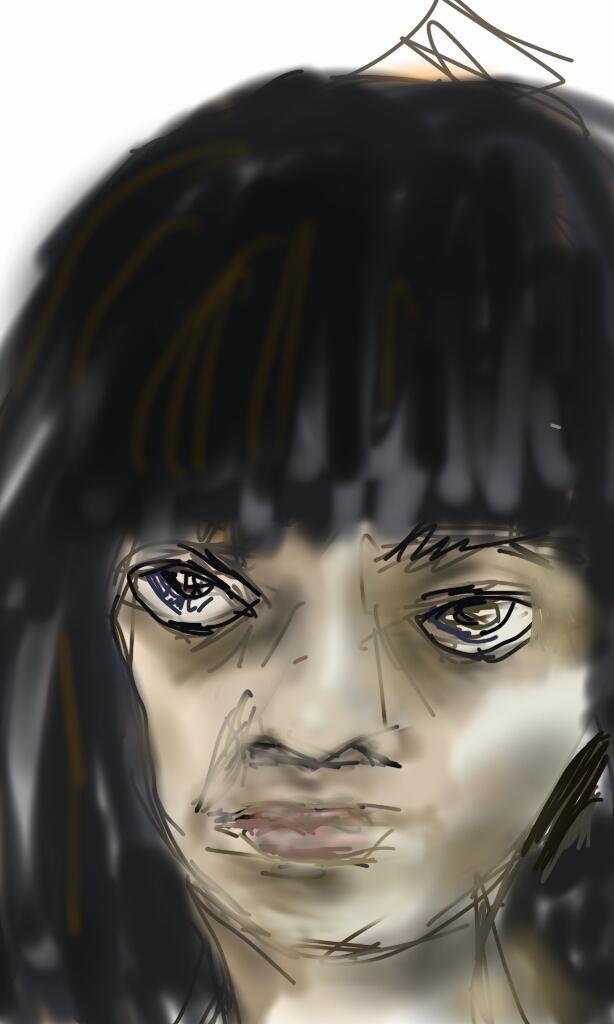In one or two sentences, can you explain what this image depicts? This picture is consists of a sketch in the image. 